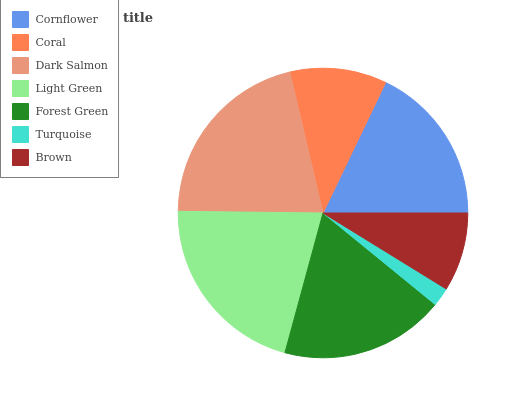Is Turquoise the minimum?
Answer yes or no. Yes. Is Dark Salmon the maximum?
Answer yes or no. Yes. Is Coral the minimum?
Answer yes or no. No. Is Coral the maximum?
Answer yes or no. No. Is Cornflower greater than Coral?
Answer yes or no. Yes. Is Coral less than Cornflower?
Answer yes or no. Yes. Is Coral greater than Cornflower?
Answer yes or no. No. Is Cornflower less than Coral?
Answer yes or no. No. Is Cornflower the high median?
Answer yes or no. Yes. Is Cornflower the low median?
Answer yes or no. Yes. Is Dark Salmon the high median?
Answer yes or no. No. Is Light Green the low median?
Answer yes or no. No. 